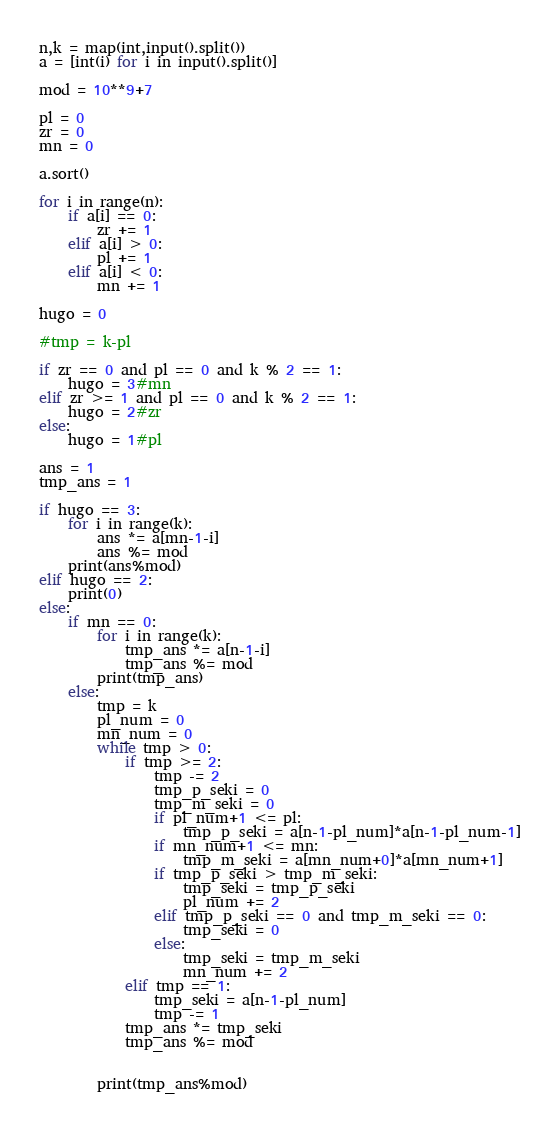Convert code to text. <code><loc_0><loc_0><loc_500><loc_500><_Python_>n,k = map(int,input().split())
a = [int(i) for i in input().split()]

mod = 10**9+7

pl = 0
zr = 0
mn = 0

a.sort()

for i in range(n):
    if a[i] == 0:
        zr += 1
    elif a[i] > 0:
        pl += 1
    elif a[i] < 0:
        mn += 1

hugo = 0

#tmp = k-pl
        
if zr == 0 and pl == 0 and k % 2 == 1:
    hugo = 3#mn
elif zr >= 1 and pl == 0 and k % 2 == 1:
    hugo = 2#zr
else:
    hugo = 1#pl

ans = 1
tmp_ans = 1
    
if hugo == 3:
    for i in range(k):
        ans *= a[mn-1-i]
        ans %= mod
    print(ans%mod)
elif hugo == 2:
    print(0)
else:
    if mn == 0:
        for i in range(k):
            tmp_ans *= a[n-1-i]
            tmp_ans %= mod
        print(tmp_ans)
    else:
        tmp = k
        pl_num = 0
        mn_num = 0
        while tmp > 0:
            if tmp >= 2:
                tmp -= 2
                tmp_p_seki = 0
                tmp_m_seki = 0
                if pl_num+1 <= pl:
                    tmp_p_seki = a[n-1-pl_num]*a[n-1-pl_num-1]
                if mn_num+1 <= mn:
                    tmp_m_seki = a[mn_num+0]*a[mn_num+1]
                if tmp_p_seki > tmp_m_seki:
                    tmp_seki = tmp_p_seki
                    pl_num += 2
                elif tmp_p_seki == 0 and tmp_m_seki == 0:
                    tmp_seki = 0
                else:
                    tmp_seki = tmp_m_seki
                    mn_num += 2
            elif tmp == 1:
                tmp_seki = a[n-1-pl_num]
                tmp -= 1
            tmp_ans *= tmp_seki
            tmp_ans %= mod
                    
            
        print(tmp_ans%mod)</code> 